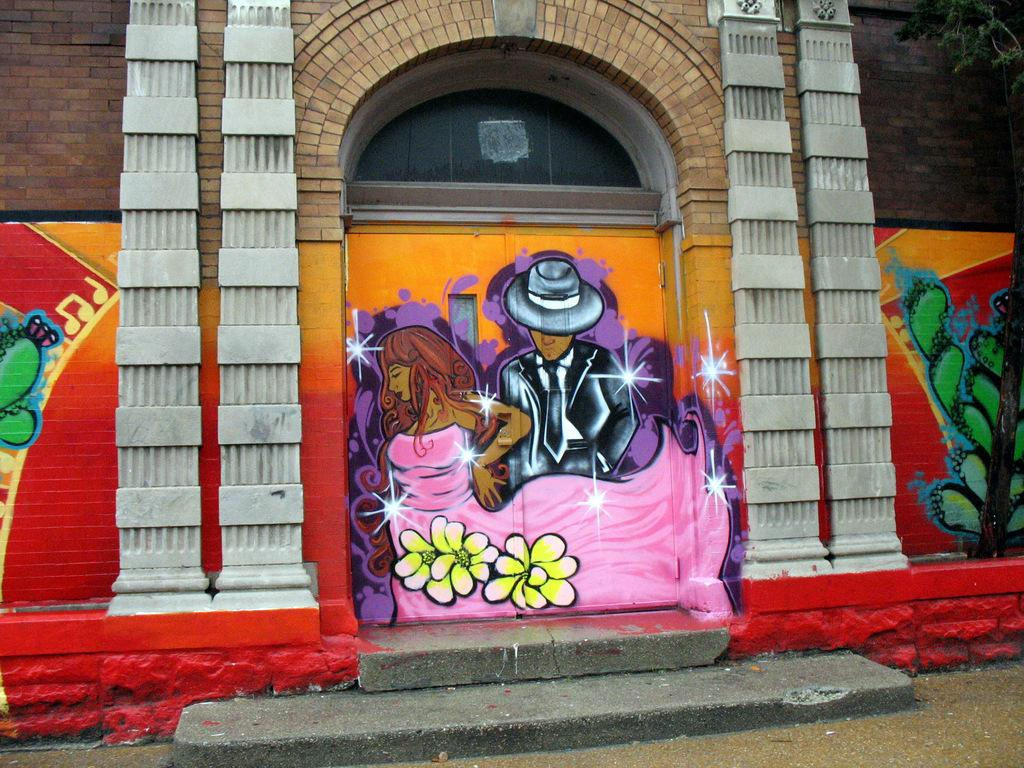What structure is the main subject of the image? There is a building in the image. What can be seen on the wall of the building? There is a painting on the wall of the building. What type of vegetation is on the right side of the image? There is a tree on the right side of the image. What architectural feature is present in the front of the image? There are steps in the front of the image. What type of vest is the tree wearing in the image? There is no vest present in the image, as trees do not wear clothing. How does the building say good-bye to the people in the image? The building does not have the ability to say good-bye, as it is an inanimate object. 